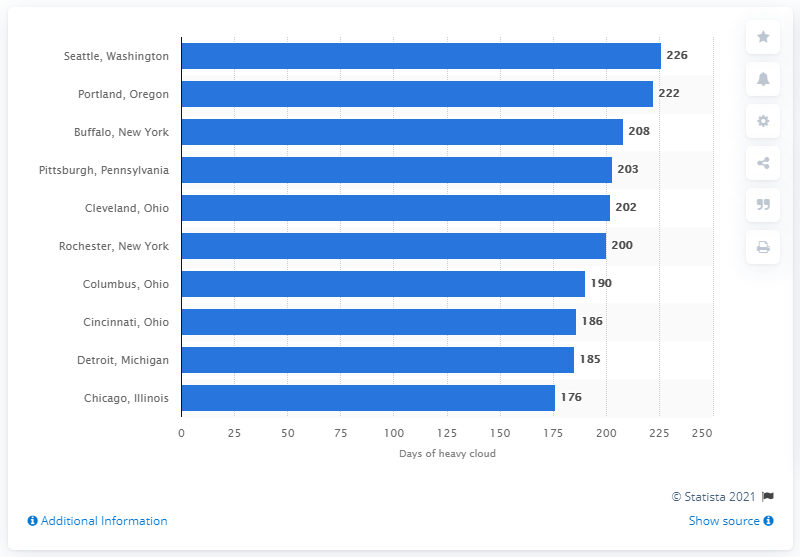Indicate a few pertinent items in this graphic. In 2011, a total of 226 days with heavy cloud cover were recorded in Seattle, Washington. The city with the highest number of heavy cloud days in 2011 was Portland, Oregon. 